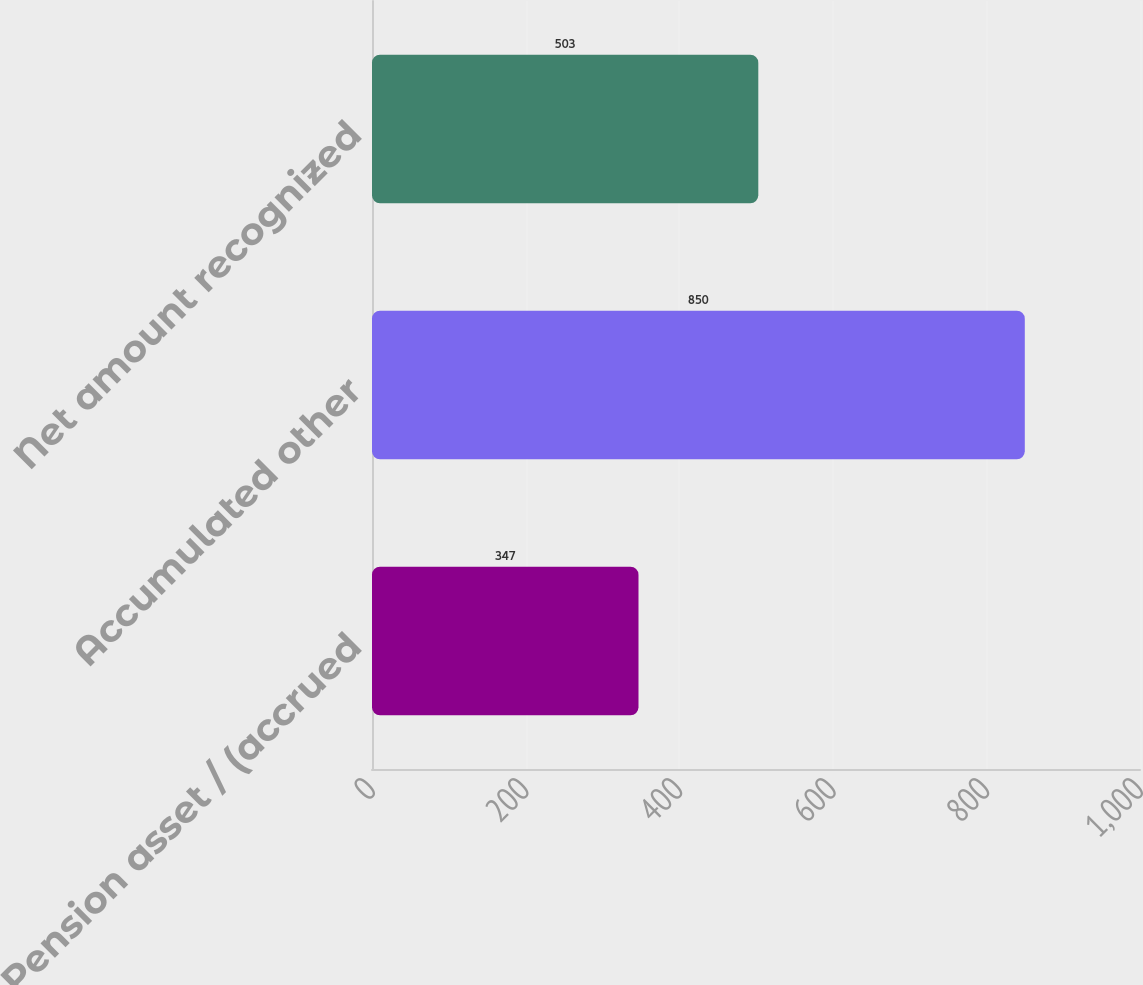Convert chart. <chart><loc_0><loc_0><loc_500><loc_500><bar_chart><fcel>Pension asset / (accrued<fcel>Accumulated other<fcel>Net amount recognized<nl><fcel>347<fcel>850<fcel>503<nl></chart> 